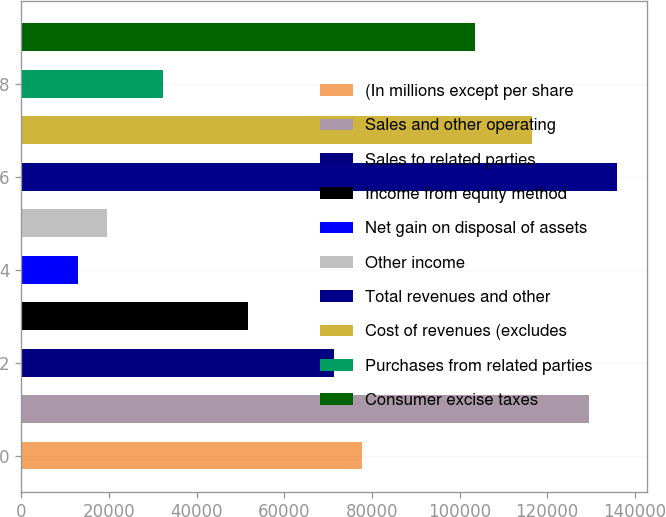<chart> <loc_0><loc_0><loc_500><loc_500><bar_chart><fcel>(In millions except per share<fcel>Sales and other operating<fcel>Sales to related parties<fcel>Income from equity method<fcel>Net gain on disposal of assets<fcel>Other income<fcel>Total revenues and other<fcel>Cost of revenues (excludes<fcel>Purchases from related parties<fcel>Consumer excise taxes<nl><fcel>77701<fcel>129501<fcel>71226<fcel>51801<fcel>12950.9<fcel>19426<fcel>135976<fcel>116551<fcel>32376<fcel>103601<nl></chart> 